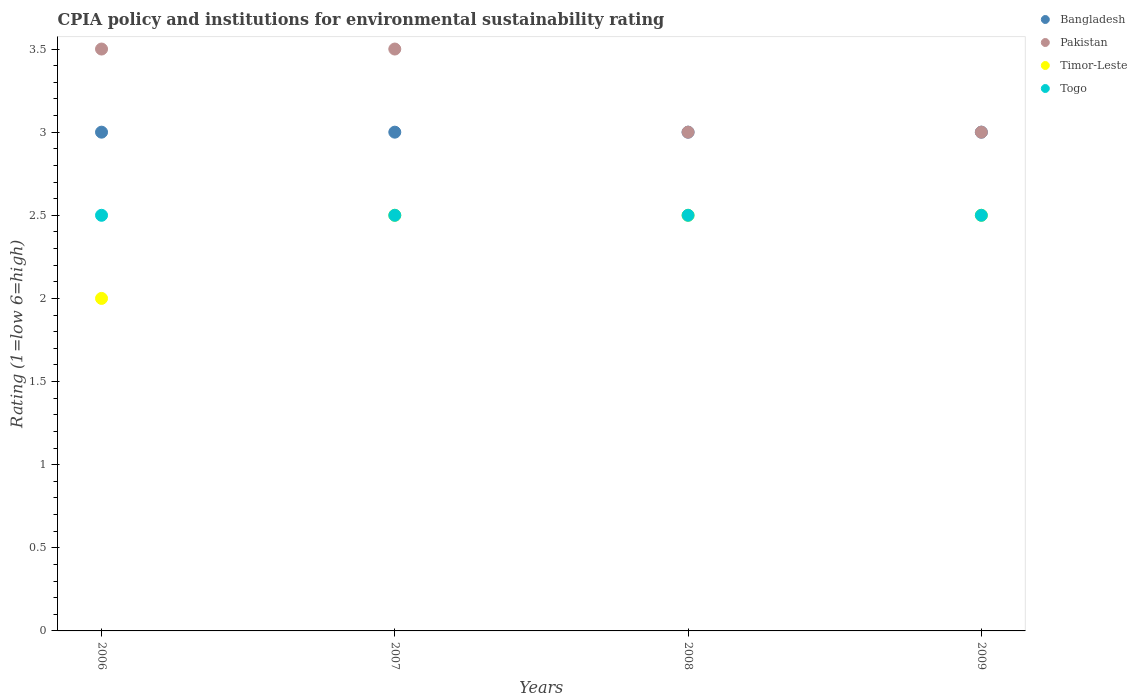In which year was the CPIA rating in Togo maximum?
Your response must be concise. 2006. In which year was the CPIA rating in Bangladesh minimum?
Offer a very short reply. 2006. What is the difference between the CPIA rating in Pakistan in 2007 and that in 2008?
Your response must be concise. 0.5. In the year 2006, what is the difference between the CPIA rating in Bangladesh and CPIA rating in Timor-Leste?
Offer a terse response. 1. In how many years, is the CPIA rating in Togo greater than 3?
Your answer should be very brief. 0. What is the ratio of the CPIA rating in Timor-Leste in 2008 to that in 2009?
Your answer should be compact. 1. Is the CPIA rating in Pakistan in 2008 less than that in 2009?
Offer a terse response. No. What is the difference between the highest and the second highest CPIA rating in Togo?
Offer a terse response. 0. In how many years, is the CPIA rating in Timor-Leste greater than the average CPIA rating in Timor-Leste taken over all years?
Give a very brief answer. 3. Is the sum of the CPIA rating in Togo in 2008 and 2009 greater than the maximum CPIA rating in Timor-Leste across all years?
Provide a succinct answer. Yes. Is it the case that in every year, the sum of the CPIA rating in Pakistan and CPIA rating in Bangladesh  is greater than the sum of CPIA rating in Togo and CPIA rating in Timor-Leste?
Offer a terse response. Yes. Is it the case that in every year, the sum of the CPIA rating in Pakistan and CPIA rating in Bangladesh  is greater than the CPIA rating in Togo?
Your answer should be compact. Yes. Is the CPIA rating in Timor-Leste strictly less than the CPIA rating in Bangladesh over the years?
Make the answer very short. Yes. How many dotlines are there?
Make the answer very short. 4. How many years are there in the graph?
Keep it short and to the point. 4. What is the difference between two consecutive major ticks on the Y-axis?
Your answer should be compact. 0.5. Does the graph contain grids?
Keep it short and to the point. No. What is the title of the graph?
Give a very brief answer. CPIA policy and institutions for environmental sustainability rating. Does "Mauritania" appear as one of the legend labels in the graph?
Ensure brevity in your answer.  No. What is the Rating (1=low 6=high) of Bangladesh in 2006?
Make the answer very short. 3. What is the Rating (1=low 6=high) in Bangladesh in 2007?
Ensure brevity in your answer.  3. What is the Rating (1=low 6=high) in Timor-Leste in 2007?
Offer a terse response. 2.5. What is the Rating (1=low 6=high) in Togo in 2007?
Ensure brevity in your answer.  2.5. What is the Rating (1=low 6=high) in Bangladesh in 2008?
Keep it short and to the point. 3. What is the Rating (1=low 6=high) in Pakistan in 2008?
Make the answer very short. 3. What is the Rating (1=low 6=high) in Bangladesh in 2009?
Give a very brief answer. 3. What is the Rating (1=low 6=high) in Pakistan in 2009?
Offer a very short reply. 3. Across all years, what is the maximum Rating (1=low 6=high) of Bangladesh?
Provide a succinct answer. 3. Across all years, what is the maximum Rating (1=low 6=high) in Togo?
Offer a terse response. 2.5. Across all years, what is the minimum Rating (1=low 6=high) in Pakistan?
Keep it short and to the point. 3. Across all years, what is the minimum Rating (1=low 6=high) in Timor-Leste?
Provide a succinct answer. 2. What is the total Rating (1=low 6=high) in Timor-Leste in the graph?
Your response must be concise. 9.5. What is the total Rating (1=low 6=high) of Togo in the graph?
Offer a terse response. 10. What is the difference between the Rating (1=low 6=high) of Pakistan in 2006 and that in 2007?
Ensure brevity in your answer.  0. What is the difference between the Rating (1=low 6=high) of Togo in 2006 and that in 2007?
Provide a succinct answer. 0. What is the difference between the Rating (1=low 6=high) in Bangladesh in 2006 and that in 2008?
Offer a very short reply. 0. What is the difference between the Rating (1=low 6=high) in Pakistan in 2006 and that in 2008?
Provide a succinct answer. 0.5. What is the difference between the Rating (1=low 6=high) of Timor-Leste in 2006 and that in 2008?
Your response must be concise. -0.5. What is the difference between the Rating (1=low 6=high) of Togo in 2006 and that in 2008?
Keep it short and to the point. 0. What is the difference between the Rating (1=low 6=high) in Bangladesh in 2006 and that in 2009?
Offer a very short reply. 0. What is the difference between the Rating (1=low 6=high) in Togo in 2006 and that in 2009?
Give a very brief answer. 0. What is the difference between the Rating (1=low 6=high) of Bangladesh in 2007 and that in 2008?
Ensure brevity in your answer.  0. What is the difference between the Rating (1=low 6=high) of Timor-Leste in 2007 and that in 2009?
Keep it short and to the point. 0. What is the difference between the Rating (1=low 6=high) in Togo in 2007 and that in 2009?
Your response must be concise. 0. What is the difference between the Rating (1=low 6=high) of Pakistan in 2008 and that in 2009?
Give a very brief answer. 0. What is the difference between the Rating (1=low 6=high) in Timor-Leste in 2008 and that in 2009?
Your answer should be very brief. 0. What is the difference between the Rating (1=low 6=high) of Bangladesh in 2006 and the Rating (1=low 6=high) of Pakistan in 2007?
Give a very brief answer. -0.5. What is the difference between the Rating (1=low 6=high) of Bangladesh in 2006 and the Rating (1=low 6=high) of Togo in 2007?
Your answer should be compact. 0.5. What is the difference between the Rating (1=low 6=high) in Pakistan in 2006 and the Rating (1=low 6=high) in Timor-Leste in 2007?
Offer a very short reply. 1. What is the difference between the Rating (1=low 6=high) in Pakistan in 2006 and the Rating (1=low 6=high) in Togo in 2007?
Keep it short and to the point. 1. What is the difference between the Rating (1=low 6=high) in Bangladesh in 2006 and the Rating (1=low 6=high) in Togo in 2008?
Your response must be concise. 0.5. What is the difference between the Rating (1=low 6=high) in Pakistan in 2006 and the Rating (1=low 6=high) in Timor-Leste in 2008?
Ensure brevity in your answer.  1. What is the difference between the Rating (1=low 6=high) in Pakistan in 2006 and the Rating (1=low 6=high) in Togo in 2008?
Give a very brief answer. 1. What is the difference between the Rating (1=low 6=high) in Timor-Leste in 2006 and the Rating (1=low 6=high) in Togo in 2008?
Give a very brief answer. -0.5. What is the difference between the Rating (1=low 6=high) in Bangladesh in 2006 and the Rating (1=low 6=high) in Pakistan in 2009?
Your response must be concise. 0. What is the difference between the Rating (1=low 6=high) in Bangladesh in 2006 and the Rating (1=low 6=high) in Timor-Leste in 2009?
Your answer should be very brief. 0.5. What is the difference between the Rating (1=low 6=high) in Pakistan in 2006 and the Rating (1=low 6=high) in Timor-Leste in 2009?
Offer a very short reply. 1. What is the difference between the Rating (1=low 6=high) in Bangladesh in 2007 and the Rating (1=low 6=high) in Pakistan in 2008?
Offer a very short reply. 0. What is the difference between the Rating (1=low 6=high) of Pakistan in 2007 and the Rating (1=low 6=high) of Timor-Leste in 2008?
Offer a terse response. 1. What is the difference between the Rating (1=low 6=high) of Pakistan in 2007 and the Rating (1=low 6=high) of Togo in 2008?
Make the answer very short. 1. What is the difference between the Rating (1=low 6=high) in Timor-Leste in 2007 and the Rating (1=low 6=high) in Togo in 2008?
Keep it short and to the point. 0. What is the difference between the Rating (1=low 6=high) of Bangladesh in 2007 and the Rating (1=low 6=high) of Timor-Leste in 2009?
Make the answer very short. 0.5. What is the difference between the Rating (1=low 6=high) of Bangladesh in 2007 and the Rating (1=low 6=high) of Togo in 2009?
Keep it short and to the point. 0.5. What is the difference between the Rating (1=low 6=high) of Bangladesh in 2008 and the Rating (1=low 6=high) of Timor-Leste in 2009?
Make the answer very short. 0.5. What is the difference between the Rating (1=low 6=high) in Bangladesh in 2008 and the Rating (1=low 6=high) in Togo in 2009?
Offer a very short reply. 0.5. What is the difference between the Rating (1=low 6=high) of Pakistan in 2008 and the Rating (1=low 6=high) of Timor-Leste in 2009?
Provide a short and direct response. 0.5. What is the average Rating (1=low 6=high) in Pakistan per year?
Your answer should be very brief. 3.25. What is the average Rating (1=low 6=high) in Timor-Leste per year?
Provide a succinct answer. 2.38. What is the average Rating (1=low 6=high) in Togo per year?
Provide a short and direct response. 2.5. In the year 2006, what is the difference between the Rating (1=low 6=high) in Bangladesh and Rating (1=low 6=high) in Pakistan?
Provide a short and direct response. -0.5. In the year 2006, what is the difference between the Rating (1=low 6=high) in Pakistan and Rating (1=low 6=high) in Timor-Leste?
Provide a short and direct response. 1.5. In the year 2006, what is the difference between the Rating (1=low 6=high) in Timor-Leste and Rating (1=low 6=high) in Togo?
Your answer should be very brief. -0.5. In the year 2007, what is the difference between the Rating (1=low 6=high) in Bangladesh and Rating (1=low 6=high) in Togo?
Give a very brief answer. 0.5. In the year 2007, what is the difference between the Rating (1=low 6=high) in Pakistan and Rating (1=low 6=high) in Timor-Leste?
Ensure brevity in your answer.  1. In the year 2007, what is the difference between the Rating (1=low 6=high) in Timor-Leste and Rating (1=low 6=high) in Togo?
Your answer should be compact. 0. In the year 2008, what is the difference between the Rating (1=low 6=high) of Bangladesh and Rating (1=low 6=high) of Pakistan?
Offer a very short reply. 0. In the year 2008, what is the difference between the Rating (1=low 6=high) of Bangladesh and Rating (1=low 6=high) of Togo?
Give a very brief answer. 0.5. What is the ratio of the Rating (1=low 6=high) of Bangladesh in 2006 to that in 2007?
Offer a very short reply. 1. What is the ratio of the Rating (1=low 6=high) of Pakistan in 2006 to that in 2007?
Provide a succinct answer. 1. What is the ratio of the Rating (1=low 6=high) in Timor-Leste in 2006 to that in 2007?
Offer a very short reply. 0.8. What is the ratio of the Rating (1=low 6=high) in Timor-Leste in 2006 to that in 2008?
Your answer should be compact. 0.8. What is the ratio of the Rating (1=low 6=high) of Bangladesh in 2006 to that in 2009?
Keep it short and to the point. 1. What is the ratio of the Rating (1=low 6=high) in Timor-Leste in 2006 to that in 2009?
Your answer should be compact. 0.8. What is the ratio of the Rating (1=low 6=high) of Togo in 2006 to that in 2009?
Offer a terse response. 1. What is the ratio of the Rating (1=low 6=high) of Bangladesh in 2007 to that in 2008?
Provide a succinct answer. 1. What is the ratio of the Rating (1=low 6=high) of Pakistan in 2007 to that in 2008?
Ensure brevity in your answer.  1.17. What is the ratio of the Rating (1=low 6=high) of Timor-Leste in 2007 to that in 2008?
Ensure brevity in your answer.  1. What is the ratio of the Rating (1=low 6=high) in Togo in 2007 to that in 2008?
Keep it short and to the point. 1. What is the ratio of the Rating (1=low 6=high) of Bangladesh in 2007 to that in 2009?
Your response must be concise. 1. What is the ratio of the Rating (1=low 6=high) of Togo in 2007 to that in 2009?
Make the answer very short. 1. What is the ratio of the Rating (1=low 6=high) of Bangladesh in 2008 to that in 2009?
Your response must be concise. 1. What is the ratio of the Rating (1=low 6=high) of Timor-Leste in 2008 to that in 2009?
Ensure brevity in your answer.  1. What is the ratio of the Rating (1=low 6=high) of Togo in 2008 to that in 2009?
Give a very brief answer. 1. What is the difference between the highest and the second highest Rating (1=low 6=high) of Pakistan?
Offer a very short reply. 0. What is the difference between the highest and the second highest Rating (1=low 6=high) in Timor-Leste?
Provide a succinct answer. 0. What is the difference between the highest and the second highest Rating (1=low 6=high) in Togo?
Offer a very short reply. 0. What is the difference between the highest and the lowest Rating (1=low 6=high) of Bangladesh?
Provide a short and direct response. 0. What is the difference between the highest and the lowest Rating (1=low 6=high) in Togo?
Offer a terse response. 0. 